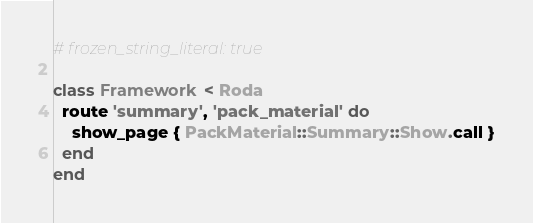Convert code to text. <code><loc_0><loc_0><loc_500><loc_500><_Ruby_># frozen_string_literal: true

class Framework < Roda
  route 'summary', 'pack_material' do
    show_page { PackMaterial::Summary::Show.call }
  end
end
</code> 